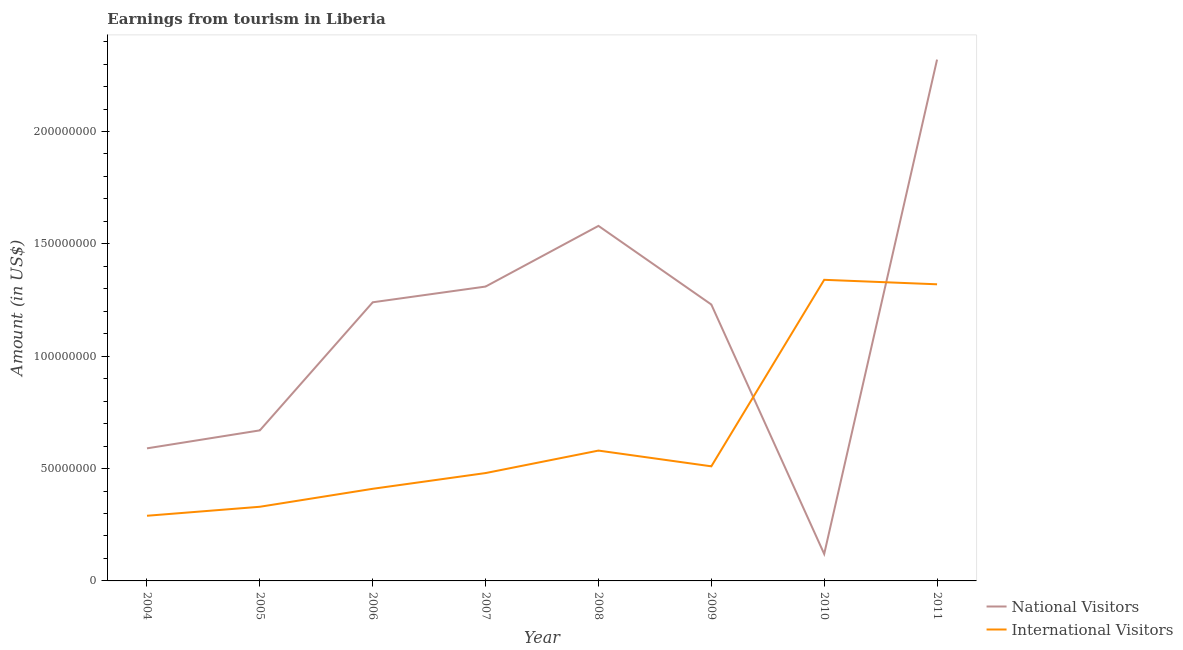Is the number of lines equal to the number of legend labels?
Provide a short and direct response. Yes. What is the amount earned from national visitors in 2007?
Make the answer very short. 1.31e+08. Across all years, what is the maximum amount earned from international visitors?
Offer a terse response. 1.34e+08. Across all years, what is the minimum amount earned from international visitors?
Provide a succinct answer. 2.90e+07. In which year was the amount earned from international visitors maximum?
Your answer should be compact. 2010. In which year was the amount earned from national visitors minimum?
Keep it short and to the point. 2010. What is the total amount earned from international visitors in the graph?
Offer a very short reply. 5.26e+08. What is the difference between the amount earned from national visitors in 2004 and that in 2009?
Provide a succinct answer. -6.40e+07. What is the difference between the amount earned from national visitors in 2007 and the amount earned from international visitors in 2006?
Provide a short and direct response. 9.00e+07. What is the average amount earned from international visitors per year?
Make the answer very short. 6.58e+07. In the year 2009, what is the difference between the amount earned from international visitors and amount earned from national visitors?
Keep it short and to the point. -7.20e+07. What is the ratio of the amount earned from national visitors in 2004 to that in 2010?
Make the answer very short. 4.92. Is the amount earned from international visitors in 2008 less than that in 2009?
Offer a terse response. No. Is the difference between the amount earned from international visitors in 2006 and 2008 greater than the difference between the amount earned from national visitors in 2006 and 2008?
Your response must be concise. Yes. What is the difference between the highest and the second highest amount earned from international visitors?
Ensure brevity in your answer.  2.00e+06. What is the difference between the highest and the lowest amount earned from national visitors?
Provide a succinct answer. 2.20e+08. Does the amount earned from national visitors monotonically increase over the years?
Your response must be concise. No. Is the amount earned from national visitors strictly greater than the amount earned from international visitors over the years?
Offer a very short reply. No. Is the amount earned from national visitors strictly less than the amount earned from international visitors over the years?
Your response must be concise. No. How many lines are there?
Your response must be concise. 2. Does the graph contain any zero values?
Make the answer very short. No. Does the graph contain grids?
Offer a very short reply. No. How are the legend labels stacked?
Provide a short and direct response. Vertical. What is the title of the graph?
Ensure brevity in your answer.  Earnings from tourism in Liberia. What is the Amount (in US$) in National Visitors in 2004?
Offer a very short reply. 5.90e+07. What is the Amount (in US$) in International Visitors in 2004?
Provide a succinct answer. 2.90e+07. What is the Amount (in US$) of National Visitors in 2005?
Your answer should be compact. 6.70e+07. What is the Amount (in US$) of International Visitors in 2005?
Provide a short and direct response. 3.30e+07. What is the Amount (in US$) of National Visitors in 2006?
Your response must be concise. 1.24e+08. What is the Amount (in US$) of International Visitors in 2006?
Offer a terse response. 4.10e+07. What is the Amount (in US$) of National Visitors in 2007?
Make the answer very short. 1.31e+08. What is the Amount (in US$) of International Visitors in 2007?
Give a very brief answer. 4.80e+07. What is the Amount (in US$) of National Visitors in 2008?
Ensure brevity in your answer.  1.58e+08. What is the Amount (in US$) of International Visitors in 2008?
Your answer should be very brief. 5.80e+07. What is the Amount (in US$) of National Visitors in 2009?
Make the answer very short. 1.23e+08. What is the Amount (in US$) of International Visitors in 2009?
Provide a succinct answer. 5.10e+07. What is the Amount (in US$) of International Visitors in 2010?
Provide a short and direct response. 1.34e+08. What is the Amount (in US$) in National Visitors in 2011?
Your answer should be very brief. 2.32e+08. What is the Amount (in US$) of International Visitors in 2011?
Ensure brevity in your answer.  1.32e+08. Across all years, what is the maximum Amount (in US$) of National Visitors?
Your answer should be very brief. 2.32e+08. Across all years, what is the maximum Amount (in US$) of International Visitors?
Make the answer very short. 1.34e+08. Across all years, what is the minimum Amount (in US$) of International Visitors?
Keep it short and to the point. 2.90e+07. What is the total Amount (in US$) of National Visitors in the graph?
Give a very brief answer. 9.06e+08. What is the total Amount (in US$) of International Visitors in the graph?
Ensure brevity in your answer.  5.26e+08. What is the difference between the Amount (in US$) of National Visitors in 2004 and that in 2005?
Ensure brevity in your answer.  -8.00e+06. What is the difference between the Amount (in US$) in International Visitors in 2004 and that in 2005?
Your response must be concise. -4.00e+06. What is the difference between the Amount (in US$) of National Visitors in 2004 and that in 2006?
Offer a terse response. -6.50e+07. What is the difference between the Amount (in US$) of International Visitors in 2004 and that in 2006?
Make the answer very short. -1.20e+07. What is the difference between the Amount (in US$) in National Visitors in 2004 and that in 2007?
Keep it short and to the point. -7.20e+07. What is the difference between the Amount (in US$) in International Visitors in 2004 and that in 2007?
Keep it short and to the point. -1.90e+07. What is the difference between the Amount (in US$) of National Visitors in 2004 and that in 2008?
Make the answer very short. -9.90e+07. What is the difference between the Amount (in US$) in International Visitors in 2004 and that in 2008?
Provide a succinct answer. -2.90e+07. What is the difference between the Amount (in US$) in National Visitors in 2004 and that in 2009?
Your answer should be very brief. -6.40e+07. What is the difference between the Amount (in US$) in International Visitors in 2004 and that in 2009?
Provide a succinct answer. -2.20e+07. What is the difference between the Amount (in US$) in National Visitors in 2004 and that in 2010?
Make the answer very short. 4.70e+07. What is the difference between the Amount (in US$) in International Visitors in 2004 and that in 2010?
Provide a short and direct response. -1.05e+08. What is the difference between the Amount (in US$) of National Visitors in 2004 and that in 2011?
Keep it short and to the point. -1.73e+08. What is the difference between the Amount (in US$) of International Visitors in 2004 and that in 2011?
Provide a short and direct response. -1.03e+08. What is the difference between the Amount (in US$) in National Visitors in 2005 and that in 2006?
Provide a succinct answer. -5.70e+07. What is the difference between the Amount (in US$) of International Visitors in 2005 and that in 2006?
Provide a short and direct response. -8.00e+06. What is the difference between the Amount (in US$) of National Visitors in 2005 and that in 2007?
Your answer should be very brief. -6.40e+07. What is the difference between the Amount (in US$) of International Visitors in 2005 and that in 2007?
Your answer should be very brief. -1.50e+07. What is the difference between the Amount (in US$) of National Visitors in 2005 and that in 2008?
Offer a terse response. -9.10e+07. What is the difference between the Amount (in US$) of International Visitors in 2005 and that in 2008?
Make the answer very short. -2.50e+07. What is the difference between the Amount (in US$) in National Visitors in 2005 and that in 2009?
Offer a terse response. -5.60e+07. What is the difference between the Amount (in US$) in International Visitors in 2005 and that in 2009?
Your response must be concise. -1.80e+07. What is the difference between the Amount (in US$) in National Visitors in 2005 and that in 2010?
Your response must be concise. 5.50e+07. What is the difference between the Amount (in US$) in International Visitors in 2005 and that in 2010?
Your answer should be very brief. -1.01e+08. What is the difference between the Amount (in US$) of National Visitors in 2005 and that in 2011?
Your answer should be very brief. -1.65e+08. What is the difference between the Amount (in US$) in International Visitors in 2005 and that in 2011?
Your answer should be very brief. -9.90e+07. What is the difference between the Amount (in US$) in National Visitors in 2006 and that in 2007?
Make the answer very short. -7.00e+06. What is the difference between the Amount (in US$) of International Visitors in 2006 and that in 2007?
Your answer should be very brief. -7.00e+06. What is the difference between the Amount (in US$) in National Visitors in 2006 and that in 2008?
Make the answer very short. -3.40e+07. What is the difference between the Amount (in US$) of International Visitors in 2006 and that in 2008?
Give a very brief answer. -1.70e+07. What is the difference between the Amount (in US$) of National Visitors in 2006 and that in 2009?
Offer a very short reply. 1.00e+06. What is the difference between the Amount (in US$) in International Visitors in 2006 and that in 2009?
Your answer should be compact. -1.00e+07. What is the difference between the Amount (in US$) of National Visitors in 2006 and that in 2010?
Offer a very short reply. 1.12e+08. What is the difference between the Amount (in US$) of International Visitors in 2006 and that in 2010?
Offer a very short reply. -9.30e+07. What is the difference between the Amount (in US$) in National Visitors in 2006 and that in 2011?
Offer a very short reply. -1.08e+08. What is the difference between the Amount (in US$) of International Visitors in 2006 and that in 2011?
Offer a very short reply. -9.10e+07. What is the difference between the Amount (in US$) in National Visitors in 2007 and that in 2008?
Offer a very short reply. -2.70e+07. What is the difference between the Amount (in US$) in International Visitors in 2007 and that in 2008?
Make the answer very short. -1.00e+07. What is the difference between the Amount (in US$) of National Visitors in 2007 and that in 2009?
Provide a succinct answer. 8.00e+06. What is the difference between the Amount (in US$) in National Visitors in 2007 and that in 2010?
Offer a very short reply. 1.19e+08. What is the difference between the Amount (in US$) in International Visitors in 2007 and that in 2010?
Your answer should be compact. -8.60e+07. What is the difference between the Amount (in US$) of National Visitors in 2007 and that in 2011?
Provide a succinct answer. -1.01e+08. What is the difference between the Amount (in US$) in International Visitors in 2007 and that in 2011?
Provide a short and direct response. -8.40e+07. What is the difference between the Amount (in US$) in National Visitors in 2008 and that in 2009?
Your answer should be very brief. 3.50e+07. What is the difference between the Amount (in US$) in National Visitors in 2008 and that in 2010?
Your response must be concise. 1.46e+08. What is the difference between the Amount (in US$) in International Visitors in 2008 and that in 2010?
Offer a terse response. -7.60e+07. What is the difference between the Amount (in US$) in National Visitors in 2008 and that in 2011?
Your answer should be compact. -7.40e+07. What is the difference between the Amount (in US$) of International Visitors in 2008 and that in 2011?
Your answer should be very brief. -7.40e+07. What is the difference between the Amount (in US$) of National Visitors in 2009 and that in 2010?
Ensure brevity in your answer.  1.11e+08. What is the difference between the Amount (in US$) of International Visitors in 2009 and that in 2010?
Provide a succinct answer. -8.30e+07. What is the difference between the Amount (in US$) in National Visitors in 2009 and that in 2011?
Offer a terse response. -1.09e+08. What is the difference between the Amount (in US$) in International Visitors in 2009 and that in 2011?
Your answer should be very brief. -8.10e+07. What is the difference between the Amount (in US$) of National Visitors in 2010 and that in 2011?
Ensure brevity in your answer.  -2.20e+08. What is the difference between the Amount (in US$) in International Visitors in 2010 and that in 2011?
Keep it short and to the point. 2.00e+06. What is the difference between the Amount (in US$) in National Visitors in 2004 and the Amount (in US$) in International Visitors in 2005?
Offer a terse response. 2.60e+07. What is the difference between the Amount (in US$) in National Visitors in 2004 and the Amount (in US$) in International Visitors in 2006?
Keep it short and to the point. 1.80e+07. What is the difference between the Amount (in US$) of National Visitors in 2004 and the Amount (in US$) of International Visitors in 2007?
Make the answer very short. 1.10e+07. What is the difference between the Amount (in US$) in National Visitors in 2004 and the Amount (in US$) in International Visitors in 2008?
Provide a succinct answer. 1.00e+06. What is the difference between the Amount (in US$) of National Visitors in 2004 and the Amount (in US$) of International Visitors in 2009?
Your answer should be very brief. 8.00e+06. What is the difference between the Amount (in US$) of National Visitors in 2004 and the Amount (in US$) of International Visitors in 2010?
Offer a terse response. -7.50e+07. What is the difference between the Amount (in US$) of National Visitors in 2004 and the Amount (in US$) of International Visitors in 2011?
Keep it short and to the point. -7.30e+07. What is the difference between the Amount (in US$) of National Visitors in 2005 and the Amount (in US$) of International Visitors in 2006?
Provide a short and direct response. 2.60e+07. What is the difference between the Amount (in US$) in National Visitors in 2005 and the Amount (in US$) in International Visitors in 2007?
Provide a succinct answer. 1.90e+07. What is the difference between the Amount (in US$) in National Visitors in 2005 and the Amount (in US$) in International Visitors in 2008?
Your answer should be very brief. 9.00e+06. What is the difference between the Amount (in US$) of National Visitors in 2005 and the Amount (in US$) of International Visitors in 2009?
Provide a short and direct response. 1.60e+07. What is the difference between the Amount (in US$) of National Visitors in 2005 and the Amount (in US$) of International Visitors in 2010?
Make the answer very short. -6.70e+07. What is the difference between the Amount (in US$) of National Visitors in 2005 and the Amount (in US$) of International Visitors in 2011?
Provide a short and direct response. -6.50e+07. What is the difference between the Amount (in US$) of National Visitors in 2006 and the Amount (in US$) of International Visitors in 2007?
Your answer should be very brief. 7.60e+07. What is the difference between the Amount (in US$) in National Visitors in 2006 and the Amount (in US$) in International Visitors in 2008?
Give a very brief answer. 6.60e+07. What is the difference between the Amount (in US$) in National Visitors in 2006 and the Amount (in US$) in International Visitors in 2009?
Keep it short and to the point. 7.30e+07. What is the difference between the Amount (in US$) of National Visitors in 2006 and the Amount (in US$) of International Visitors in 2010?
Make the answer very short. -1.00e+07. What is the difference between the Amount (in US$) of National Visitors in 2006 and the Amount (in US$) of International Visitors in 2011?
Keep it short and to the point. -8.00e+06. What is the difference between the Amount (in US$) in National Visitors in 2007 and the Amount (in US$) in International Visitors in 2008?
Provide a succinct answer. 7.30e+07. What is the difference between the Amount (in US$) in National Visitors in 2007 and the Amount (in US$) in International Visitors in 2009?
Your answer should be very brief. 8.00e+07. What is the difference between the Amount (in US$) in National Visitors in 2008 and the Amount (in US$) in International Visitors in 2009?
Your answer should be compact. 1.07e+08. What is the difference between the Amount (in US$) in National Visitors in 2008 and the Amount (in US$) in International Visitors in 2010?
Your answer should be very brief. 2.40e+07. What is the difference between the Amount (in US$) in National Visitors in 2008 and the Amount (in US$) in International Visitors in 2011?
Your answer should be very brief. 2.60e+07. What is the difference between the Amount (in US$) of National Visitors in 2009 and the Amount (in US$) of International Visitors in 2010?
Provide a short and direct response. -1.10e+07. What is the difference between the Amount (in US$) in National Visitors in 2009 and the Amount (in US$) in International Visitors in 2011?
Offer a very short reply. -9.00e+06. What is the difference between the Amount (in US$) of National Visitors in 2010 and the Amount (in US$) of International Visitors in 2011?
Your response must be concise. -1.20e+08. What is the average Amount (in US$) of National Visitors per year?
Keep it short and to the point. 1.13e+08. What is the average Amount (in US$) of International Visitors per year?
Give a very brief answer. 6.58e+07. In the year 2004, what is the difference between the Amount (in US$) in National Visitors and Amount (in US$) in International Visitors?
Provide a short and direct response. 3.00e+07. In the year 2005, what is the difference between the Amount (in US$) of National Visitors and Amount (in US$) of International Visitors?
Provide a short and direct response. 3.40e+07. In the year 2006, what is the difference between the Amount (in US$) in National Visitors and Amount (in US$) in International Visitors?
Offer a very short reply. 8.30e+07. In the year 2007, what is the difference between the Amount (in US$) of National Visitors and Amount (in US$) of International Visitors?
Offer a terse response. 8.30e+07. In the year 2009, what is the difference between the Amount (in US$) in National Visitors and Amount (in US$) in International Visitors?
Offer a very short reply. 7.20e+07. In the year 2010, what is the difference between the Amount (in US$) in National Visitors and Amount (in US$) in International Visitors?
Ensure brevity in your answer.  -1.22e+08. What is the ratio of the Amount (in US$) of National Visitors in 2004 to that in 2005?
Provide a succinct answer. 0.88. What is the ratio of the Amount (in US$) in International Visitors in 2004 to that in 2005?
Make the answer very short. 0.88. What is the ratio of the Amount (in US$) in National Visitors in 2004 to that in 2006?
Make the answer very short. 0.48. What is the ratio of the Amount (in US$) of International Visitors in 2004 to that in 2006?
Ensure brevity in your answer.  0.71. What is the ratio of the Amount (in US$) in National Visitors in 2004 to that in 2007?
Provide a succinct answer. 0.45. What is the ratio of the Amount (in US$) of International Visitors in 2004 to that in 2007?
Your answer should be very brief. 0.6. What is the ratio of the Amount (in US$) of National Visitors in 2004 to that in 2008?
Your answer should be compact. 0.37. What is the ratio of the Amount (in US$) in National Visitors in 2004 to that in 2009?
Offer a very short reply. 0.48. What is the ratio of the Amount (in US$) in International Visitors in 2004 to that in 2009?
Your response must be concise. 0.57. What is the ratio of the Amount (in US$) of National Visitors in 2004 to that in 2010?
Provide a succinct answer. 4.92. What is the ratio of the Amount (in US$) of International Visitors in 2004 to that in 2010?
Offer a very short reply. 0.22. What is the ratio of the Amount (in US$) of National Visitors in 2004 to that in 2011?
Your response must be concise. 0.25. What is the ratio of the Amount (in US$) in International Visitors in 2004 to that in 2011?
Your response must be concise. 0.22. What is the ratio of the Amount (in US$) of National Visitors in 2005 to that in 2006?
Ensure brevity in your answer.  0.54. What is the ratio of the Amount (in US$) in International Visitors in 2005 to that in 2006?
Give a very brief answer. 0.8. What is the ratio of the Amount (in US$) of National Visitors in 2005 to that in 2007?
Make the answer very short. 0.51. What is the ratio of the Amount (in US$) of International Visitors in 2005 to that in 2007?
Make the answer very short. 0.69. What is the ratio of the Amount (in US$) of National Visitors in 2005 to that in 2008?
Ensure brevity in your answer.  0.42. What is the ratio of the Amount (in US$) of International Visitors in 2005 to that in 2008?
Your answer should be very brief. 0.57. What is the ratio of the Amount (in US$) of National Visitors in 2005 to that in 2009?
Offer a terse response. 0.54. What is the ratio of the Amount (in US$) in International Visitors in 2005 to that in 2009?
Give a very brief answer. 0.65. What is the ratio of the Amount (in US$) in National Visitors in 2005 to that in 2010?
Make the answer very short. 5.58. What is the ratio of the Amount (in US$) in International Visitors in 2005 to that in 2010?
Ensure brevity in your answer.  0.25. What is the ratio of the Amount (in US$) in National Visitors in 2005 to that in 2011?
Make the answer very short. 0.29. What is the ratio of the Amount (in US$) of International Visitors in 2005 to that in 2011?
Your answer should be compact. 0.25. What is the ratio of the Amount (in US$) of National Visitors in 2006 to that in 2007?
Give a very brief answer. 0.95. What is the ratio of the Amount (in US$) in International Visitors in 2006 to that in 2007?
Your answer should be compact. 0.85. What is the ratio of the Amount (in US$) of National Visitors in 2006 to that in 2008?
Your answer should be very brief. 0.78. What is the ratio of the Amount (in US$) of International Visitors in 2006 to that in 2008?
Give a very brief answer. 0.71. What is the ratio of the Amount (in US$) in International Visitors in 2006 to that in 2009?
Offer a very short reply. 0.8. What is the ratio of the Amount (in US$) in National Visitors in 2006 to that in 2010?
Ensure brevity in your answer.  10.33. What is the ratio of the Amount (in US$) of International Visitors in 2006 to that in 2010?
Make the answer very short. 0.31. What is the ratio of the Amount (in US$) in National Visitors in 2006 to that in 2011?
Keep it short and to the point. 0.53. What is the ratio of the Amount (in US$) in International Visitors in 2006 to that in 2011?
Your answer should be very brief. 0.31. What is the ratio of the Amount (in US$) in National Visitors in 2007 to that in 2008?
Your answer should be very brief. 0.83. What is the ratio of the Amount (in US$) in International Visitors in 2007 to that in 2008?
Your response must be concise. 0.83. What is the ratio of the Amount (in US$) in National Visitors in 2007 to that in 2009?
Provide a succinct answer. 1.06. What is the ratio of the Amount (in US$) in International Visitors in 2007 to that in 2009?
Your answer should be very brief. 0.94. What is the ratio of the Amount (in US$) in National Visitors in 2007 to that in 2010?
Keep it short and to the point. 10.92. What is the ratio of the Amount (in US$) in International Visitors in 2007 to that in 2010?
Ensure brevity in your answer.  0.36. What is the ratio of the Amount (in US$) of National Visitors in 2007 to that in 2011?
Provide a short and direct response. 0.56. What is the ratio of the Amount (in US$) of International Visitors in 2007 to that in 2011?
Provide a short and direct response. 0.36. What is the ratio of the Amount (in US$) of National Visitors in 2008 to that in 2009?
Provide a succinct answer. 1.28. What is the ratio of the Amount (in US$) in International Visitors in 2008 to that in 2009?
Keep it short and to the point. 1.14. What is the ratio of the Amount (in US$) in National Visitors in 2008 to that in 2010?
Offer a very short reply. 13.17. What is the ratio of the Amount (in US$) in International Visitors in 2008 to that in 2010?
Your answer should be very brief. 0.43. What is the ratio of the Amount (in US$) of National Visitors in 2008 to that in 2011?
Offer a terse response. 0.68. What is the ratio of the Amount (in US$) of International Visitors in 2008 to that in 2011?
Offer a terse response. 0.44. What is the ratio of the Amount (in US$) of National Visitors in 2009 to that in 2010?
Offer a terse response. 10.25. What is the ratio of the Amount (in US$) of International Visitors in 2009 to that in 2010?
Your answer should be very brief. 0.38. What is the ratio of the Amount (in US$) of National Visitors in 2009 to that in 2011?
Offer a terse response. 0.53. What is the ratio of the Amount (in US$) in International Visitors in 2009 to that in 2011?
Offer a very short reply. 0.39. What is the ratio of the Amount (in US$) in National Visitors in 2010 to that in 2011?
Provide a succinct answer. 0.05. What is the ratio of the Amount (in US$) of International Visitors in 2010 to that in 2011?
Your answer should be compact. 1.02. What is the difference between the highest and the second highest Amount (in US$) in National Visitors?
Provide a succinct answer. 7.40e+07. What is the difference between the highest and the lowest Amount (in US$) of National Visitors?
Keep it short and to the point. 2.20e+08. What is the difference between the highest and the lowest Amount (in US$) of International Visitors?
Your answer should be very brief. 1.05e+08. 